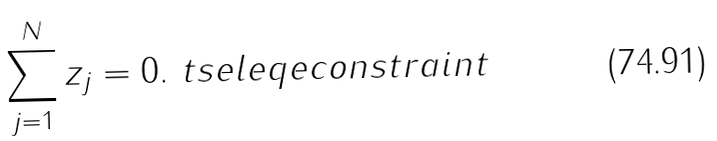Convert formula to latex. <formula><loc_0><loc_0><loc_500><loc_500>\sum _ { j = 1 } ^ { N } z _ { j } = 0 . \ t s e l e q { e c o n s t r a i n t }</formula> 